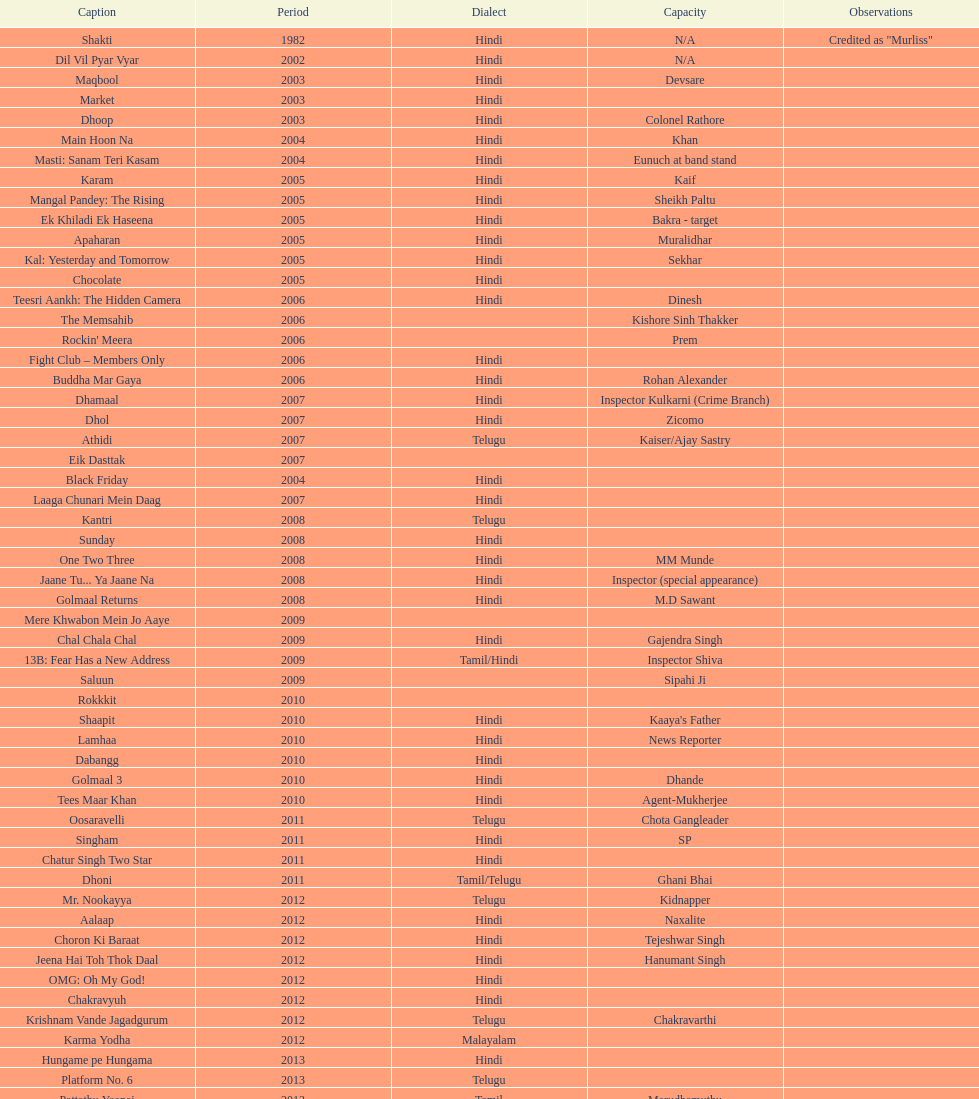What are the number of titles listed in 2005? 6. 